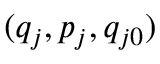Convert formula to latex. <formula><loc_0><loc_0><loc_500><loc_500>( q _ { j } , p _ { j } , q _ { j 0 } )</formula> 